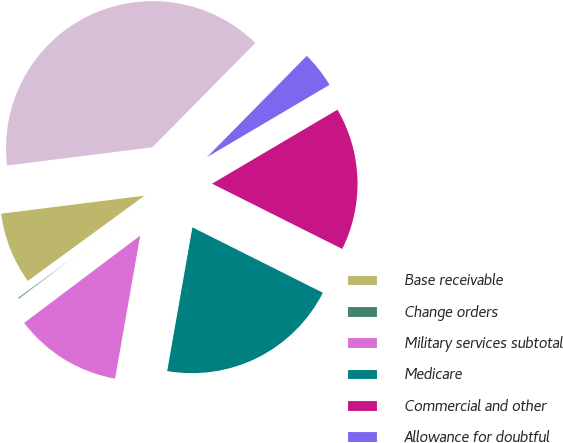Convert chart. <chart><loc_0><loc_0><loc_500><loc_500><pie_chart><fcel>Base receivable<fcel>Change orders<fcel>Military services subtotal<fcel>Medicare<fcel>Commercial and other<fcel>Allowance for doubtful<fcel>Total net receivables<nl><fcel>8.05%<fcel>0.22%<fcel>11.97%<fcel>20.37%<fcel>15.88%<fcel>4.13%<fcel>39.38%<nl></chart> 